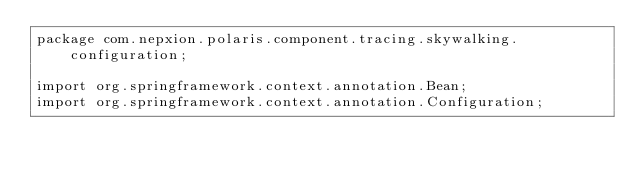<code> <loc_0><loc_0><loc_500><loc_500><_Java_>package com.nepxion.polaris.component.tracing.skywalking.configuration;

import org.springframework.context.annotation.Bean;
import org.springframework.context.annotation.Configuration;
</code> 